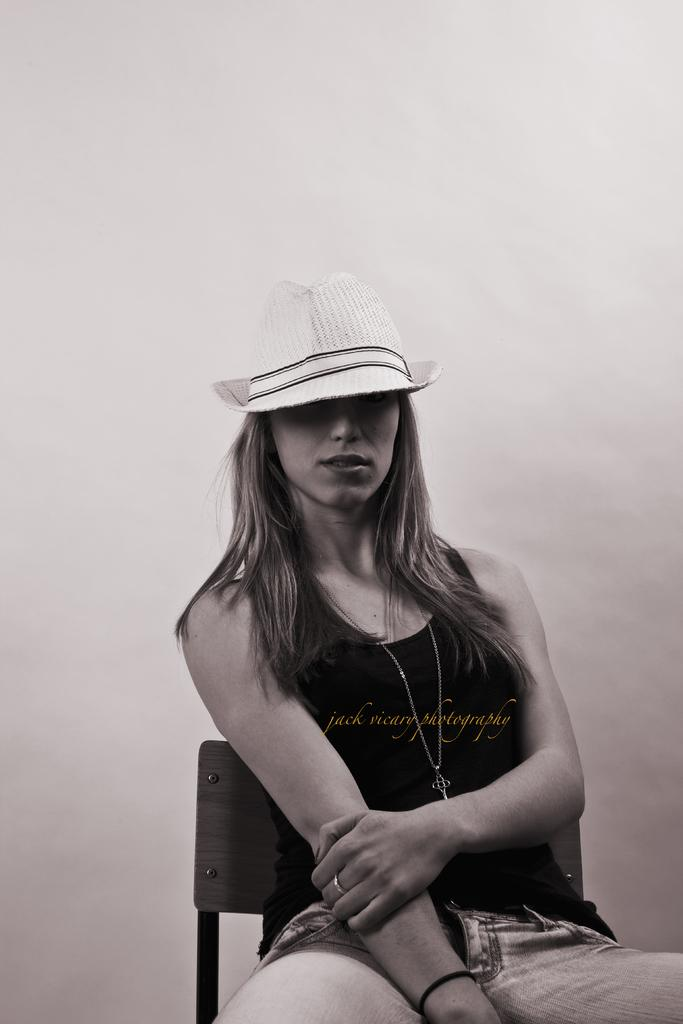Who is present in the image? There is a woman in the image. What is the woman wearing on her head? The woman is wearing a hat. What is the woman doing in the image? The woman is sitting on a chair. What can be seen behind the woman in the image? There is a plain wall in the background of the image. What type of juice is the woman holding in the image? There is no juice present in the image; the woman is not holding any beverage. 